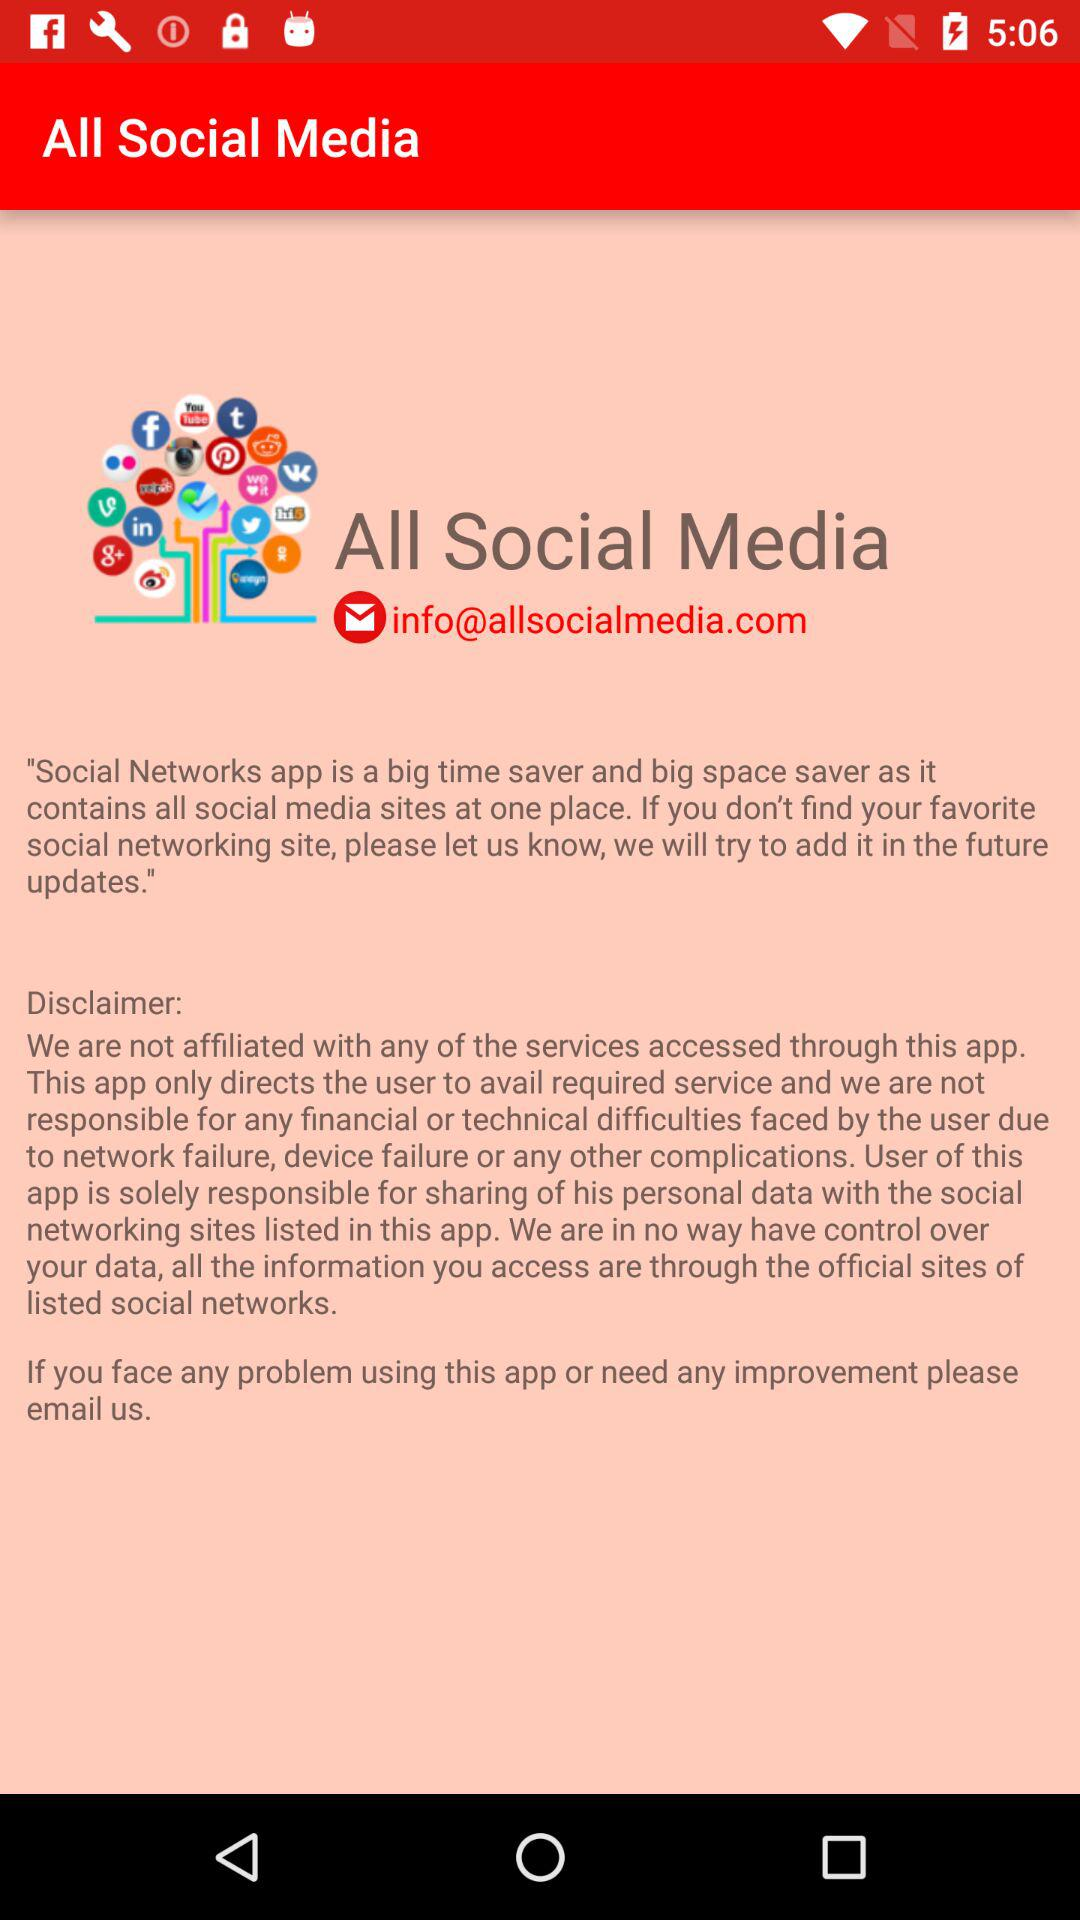What is the name of the application? The name of the application is "All Social Media". 